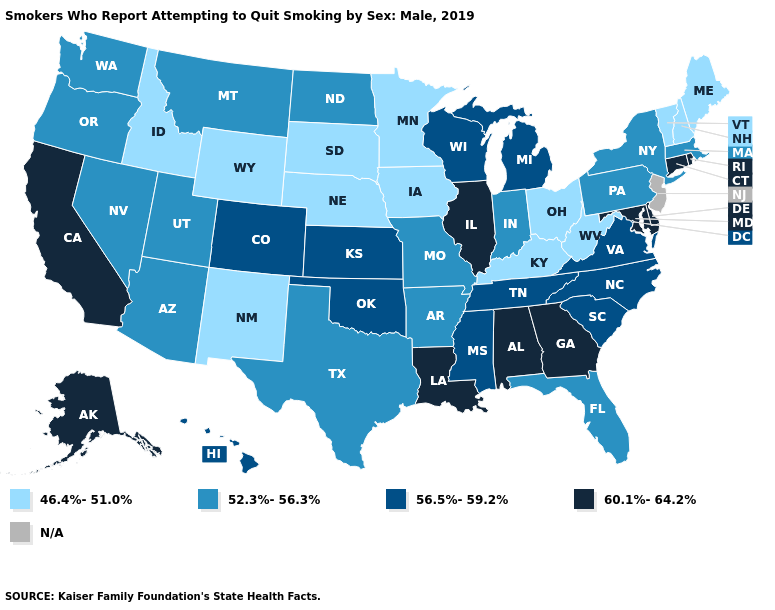Does Indiana have the lowest value in the USA?
Be succinct. No. Does Washington have the highest value in the West?
Quick response, please. No. What is the lowest value in the South?
Concise answer only. 46.4%-51.0%. Name the states that have a value in the range 60.1%-64.2%?
Short answer required. Alabama, Alaska, California, Connecticut, Delaware, Georgia, Illinois, Louisiana, Maryland, Rhode Island. Among the states that border Arizona , which have the highest value?
Concise answer only. California. What is the value of Michigan?
Short answer required. 56.5%-59.2%. Name the states that have a value in the range 52.3%-56.3%?
Give a very brief answer. Arizona, Arkansas, Florida, Indiana, Massachusetts, Missouri, Montana, Nevada, New York, North Dakota, Oregon, Pennsylvania, Texas, Utah, Washington. Name the states that have a value in the range 46.4%-51.0%?
Answer briefly. Idaho, Iowa, Kentucky, Maine, Minnesota, Nebraska, New Hampshire, New Mexico, Ohio, South Dakota, Vermont, West Virginia, Wyoming. Does Mississippi have the lowest value in the South?
Short answer required. No. What is the value of Kentucky?
Answer briefly. 46.4%-51.0%. Name the states that have a value in the range 52.3%-56.3%?
Quick response, please. Arizona, Arkansas, Florida, Indiana, Massachusetts, Missouri, Montana, Nevada, New York, North Dakota, Oregon, Pennsylvania, Texas, Utah, Washington. What is the lowest value in states that border South Carolina?
Write a very short answer. 56.5%-59.2%. Does Illinois have the highest value in the USA?
Answer briefly. Yes. Name the states that have a value in the range 46.4%-51.0%?
Answer briefly. Idaho, Iowa, Kentucky, Maine, Minnesota, Nebraska, New Hampshire, New Mexico, Ohio, South Dakota, Vermont, West Virginia, Wyoming. 